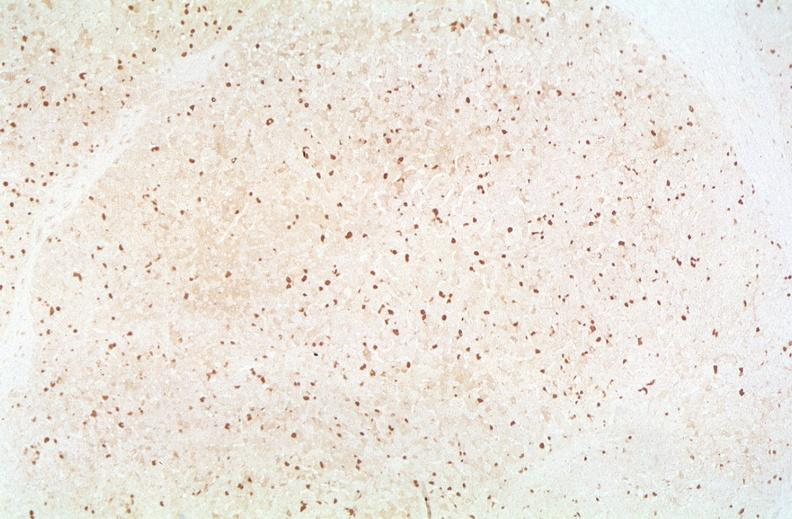s liver present?
Answer the question using a single word or phrase. Yes 